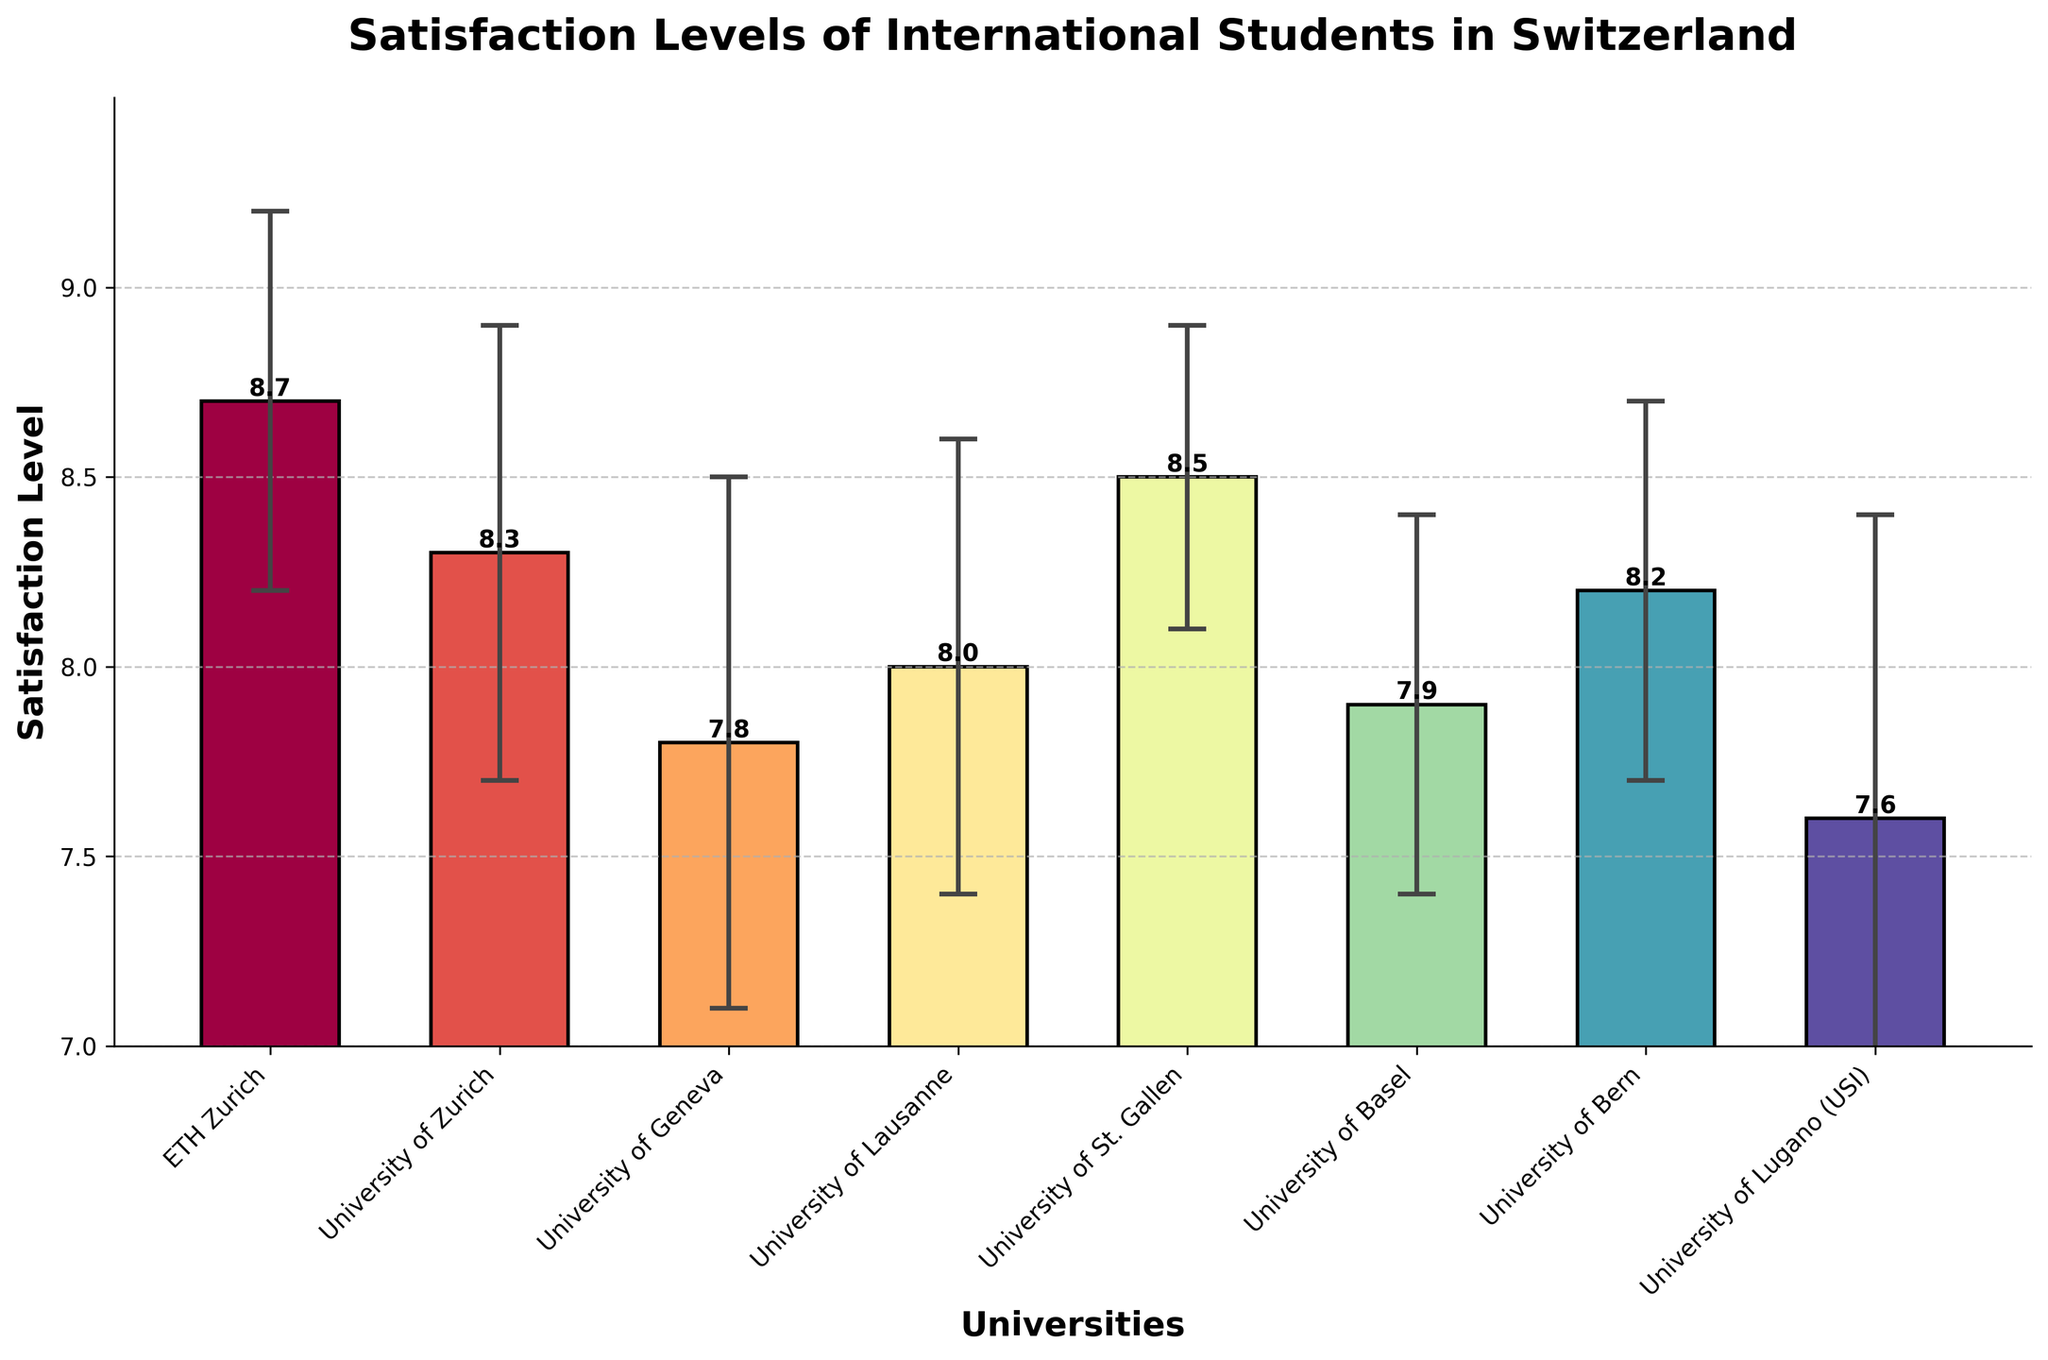What's the title of the bar chart? The title is positioned at the top of the bar chart and typically describes what the chart represents. In this case, the title will mention the satisfaction levels of international students in Switzerland.
Answer: Satisfaction Levels of International Students in Switzerland What is the axis label for the x-axis? The label for the x-axis is found at the bottom of the chart, typically indicating what kind of data is being compared along this axis. In this case, it should mention the universities.
Answer: Universities Which university has the highest mean satisfaction level? To find this, look for the tallest bar on the chart, which represents the highest satisfaction level. This bar corresponds to ETH Zurich.
Answer: ETH Zurich How many universities have a mean satisfaction level of 8.0 or higher? Count the bars with heights at or above the 8.0 mark on the y-axis. These bars represent the universities: ETH Zurich, University of Zurich, University of Lausanne, University of St. Gallen, and University of Bern.
Answer: 5 What is the mean satisfaction level of the University of Geneva? Identify the bar corresponding to the University of Geneva and read the numerical value of its height. This value is explicitly written on top of the bar.
Answer: 7.8 Which university has the largest standard deviation? The bars with the largest error bars vertically have the largest standard deviation. The University of Lugano (USI) shows the largest error bar.
Answer: University of Lugano (USI) What is the difference in mean satisfaction level between ETH Zurich and the University of Bern? Identify the mean satisfaction levels for both universities from their respective bars: ETH Zurich is 8.7 and the University of Bern is 8.2. Subtract the smaller value from the larger one.
Answer: 0.5 Which university has a lower mean satisfaction level than the University of St. Gallen but higher than the University of Geneva? Locate the bars for the University of St. Gallen (8.5) and the University of Geneva (7.8). The University of Lausanne (8.0) and the University of Zurich (8.3) fall between these two values. But the closest one is the University of Zurich.
Answer: University of Zurich What is the range of the mean satisfaction levels across all universities? Identify the highest (ETH Zurich, 8.7) and lowest (University of Lugano, 7.6) mean satisfaction levels and subtract the smallest value from the largest.
Answer: 1.1 How does the error bar of the University of Lausanne compare to that of the University of Zurich? Check the length of the vertical lines (error bars) for both universities. The standard deviation for the University of Lausanne is 0.6, and for the University of Zurich, it is 0.6, meaning they are equal.
Answer: They are equal 